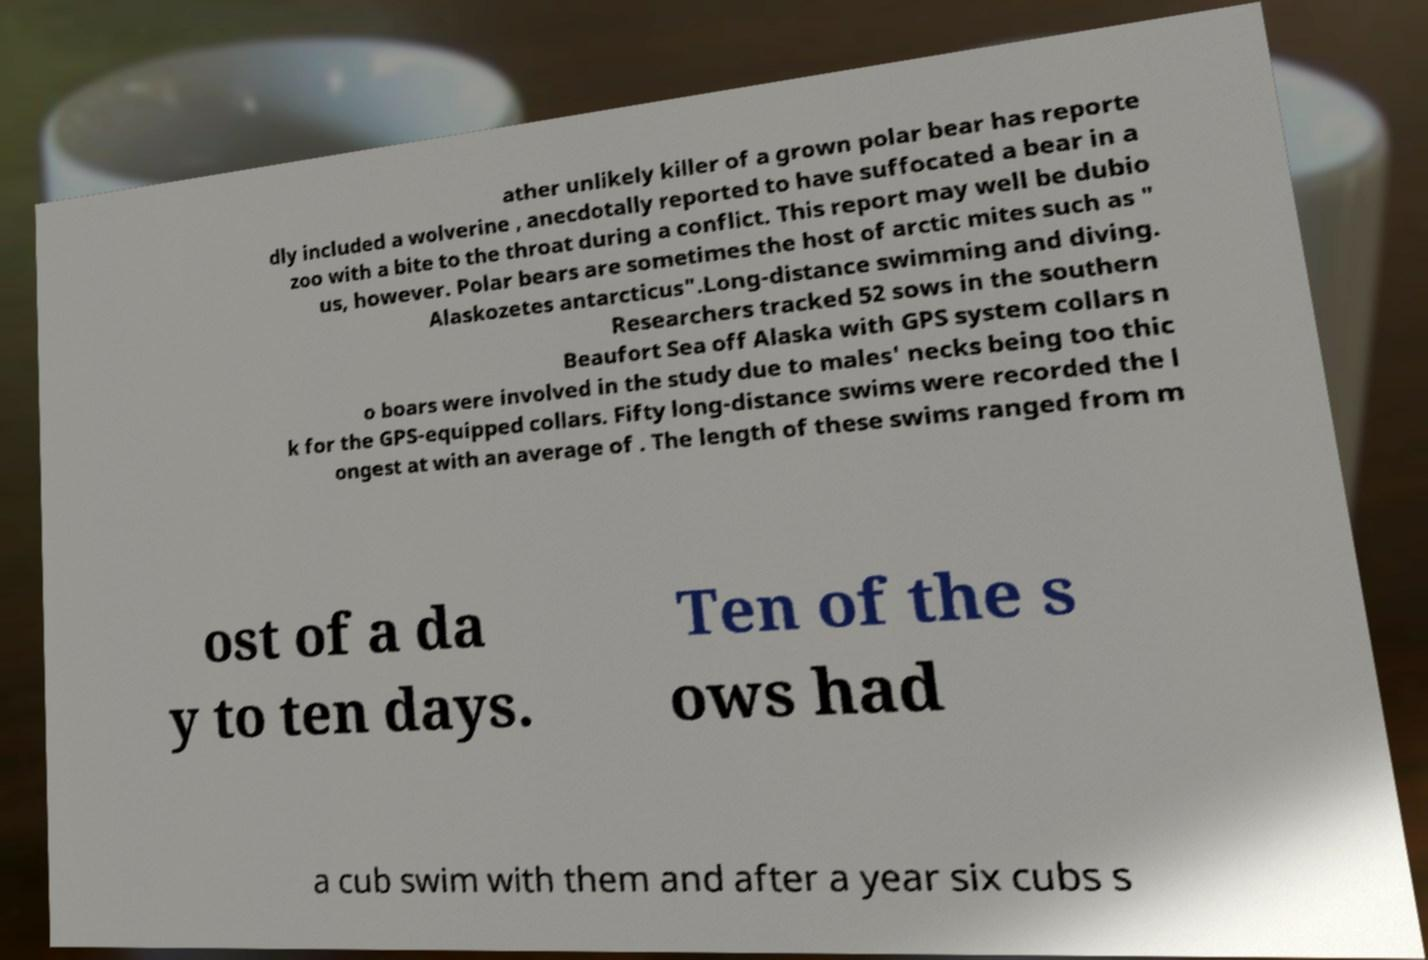Can you read and provide the text displayed in the image?This photo seems to have some interesting text. Can you extract and type it out for me? ather unlikely killer of a grown polar bear has reporte dly included a wolverine , anecdotally reported to have suffocated a bear in a zoo with a bite to the throat during a conflict. This report may well be dubio us, however. Polar bears are sometimes the host of arctic mites such as " Alaskozetes antarcticus".Long-distance swimming and diving. Researchers tracked 52 sows in the southern Beaufort Sea off Alaska with GPS system collars n o boars were involved in the study due to males' necks being too thic k for the GPS-equipped collars. Fifty long-distance swims were recorded the l ongest at with an average of . The length of these swims ranged from m ost of a da y to ten days. Ten of the s ows had a cub swim with them and after a year six cubs s 